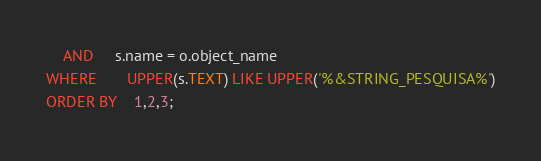Convert code to text. <code><loc_0><loc_0><loc_500><loc_500><_SQL_>    AND     s.name = o.object_name
WHERE       UPPER(s.TEXT) LIKE UPPER('%&STRING_PESQUISA%')
ORDER BY    1,2,3;

</code> 